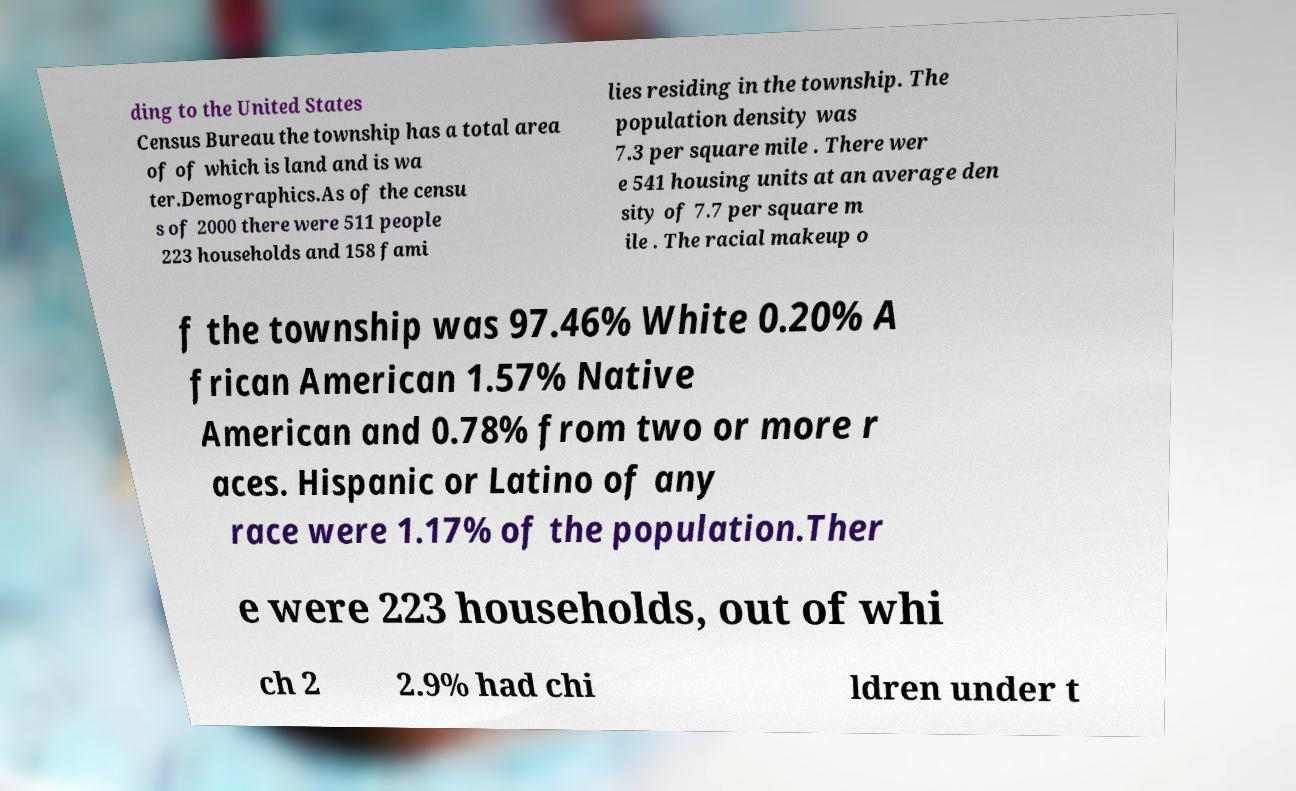Please identify and transcribe the text found in this image. ding to the United States Census Bureau the township has a total area of of which is land and is wa ter.Demographics.As of the censu s of 2000 there were 511 people 223 households and 158 fami lies residing in the township. The population density was 7.3 per square mile . There wer e 541 housing units at an average den sity of 7.7 per square m ile . The racial makeup o f the township was 97.46% White 0.20% A frican American 1.57% Native American and 0.78% from two or more r aces. Hispanic or Latino of any race were 1.17% of the population.Ther e were 223 households, out of whi ch 2 2.9% had chi ldren under t 